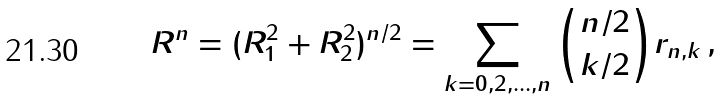<formula> <loc_0><loc_0><loc_500><loc_500>R ^ { n } = ( R _ { 1 } ^ { 2 } + R _ { 2 } ^ { 2 } ) ^ { n / 2 } = \sum _ { k = 0 , 2 , \dots , n } \binom { n / 2 } { k / 2 } r _ { n , k } \, ,</formula> 